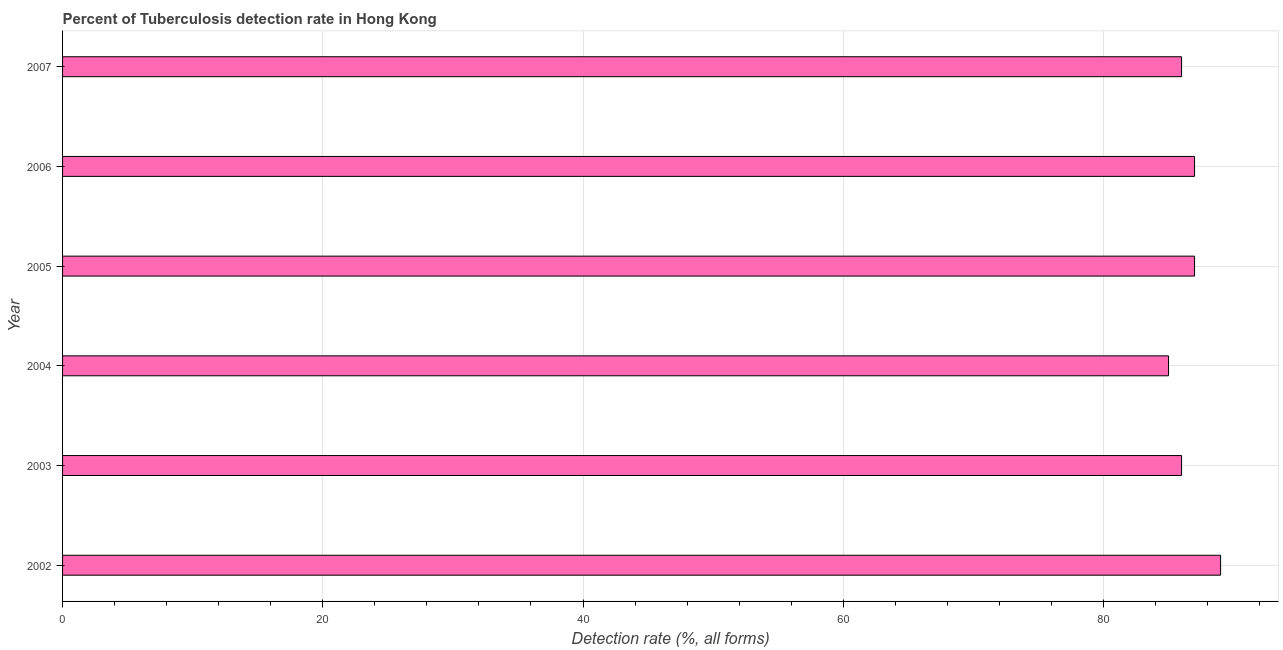Does the graph contain grids?
Offer a very short reply. Yes. What is the title of the graph?
Your response must be concise. Percent of Tuberculosis detection rate in Hong Kong. What is the label or title of the X-axis?
Offer a terse response. Detection rate (%, all forms). Across all years, what is the maximum detection rate of tuberculosis?
Make the answer very short. 89. Across all years, what is the minimum detection rate of tuberculosis?
Offer a very short reply. 85. In which year was the detection rate of tuberculosis maximum?
Your answer should be compact. 2002. In which year was the detection rate of tuberculosis minimum?
Ensure brevity in your answer.  2004. What is the sum of the detection rate of tuberculosis?
Offer a terse response. 520. What is the difference between the detection rate of tuberculosis in 2002 and 2007?
Provide a succinct answer. 3. What is the average detection rate of tuberculosis per year?
Your answer should be compact. 86. What is the median detection rate of tuberculosis?
Your answer should be very brief. 86.5. In how many years, is the detection rate of tuberculosis greater than 28 %?
Make the answer very short. 6. Do a majority of the years between 2007 and 2005 (inclusive) have detection rate of tuberculosis greater than 24 %?
Ensure brevity in your answer.  Yes. What is the ratio of the detection rate of tuberculosis in 2005 to that in 2006?
Ensure brevity in your answer.  1. Is the detection rate of tuberculosis in 2005 less than that in 2006?
Your response must be concise. No. What is the difference between the highest and the lowest detection rate of tuberculosis?
Give a very brief answer. 4. In how many years, is the detection rate of tuberculosis greater than the average detection rate of tuberculosis taken over all years?
Your answer should be very brief. 3. Are all the bars in the graph horizontal?
Your answer should be compact. Yes. How many years are there in the graph?
Keep it short and to the point. 6. Are the values on the major ticks of X-axis written in scientific E-notation?
Provide a short and direct response. No. What is the Detection rate (%, all forms) of 2002?
Your response must be concise. 89. What is the Detection rate (%, all forms) in 2004?
Keep it short and to the point. 85. What is the Detection rate (%, all forms) in 2006?
Give a very brief answer. 87. What is the Detection rate (%, all forms) of 2007?
Keep it short and to the point. 86. What is the difference between the Detection rate (%, all forms) in 2002 and 2003?
Your answer should be compact. 3. What is the difference between the Detection rate (%, all forms) in 2002 and 2004?
Keep it short and to the point. 4. What is the difference between the Detection rate (%, all forms) in 2002 and 2005?
Provide a succinct answer. 2. What is the difference between the Detection rate (%, all forms) in 2002 and 2006?
Your response must be concise. 2. What is the difference between the Detection rate (%, all forms) in 2004 and 2005?
Your response must be concise. -2. What is the difference between the Detection rate (%, all forms) in 2004 and 2006?
Your response must be concise. -2. What is the ratio of the Detection rate (%, all forms) in 2002 to that in 2003?
Ensure brevity in your answer.  1.03. What is the ratio of the Detection rate (%, all forms) in 2002 to that in 2004?
Ensure brevity in your answer.  1.05. What is the ratio of the Detection rate (%, all forms) in 2002 to that in 2005?
Offer a terse response. 1.02. What is the ratio of the Detection rate (%, all forms) in 2002 to that in 2006?
Offer a terse response. 1.02. What is the ratio of the Detection rate (%, all forms) in 2002 to that in 2007?
Your answer should be very brief. 1.03. What is the ratio of the Detection rate (%, all forms) in 2004 to that in 2005?
Give a very brief answer. 0.98. What is the ratio of the Detection rate (%, all forms) in 2004 to that in 2006?
Make the answer very short. 0.98. What is the ratio of the Detection rate (%, all forms) in 2004 to that in 2007?
Give a very brief answer. 0.99. What is the ratio of the Detection rate (%, all forms) in 2005 to that in 2007?
Your response must be concise. 1.01. 